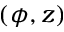Convert formula to latex. <formula><loc_0><loc_0><loc_500><loc_500>( \phi , z )</formula> 